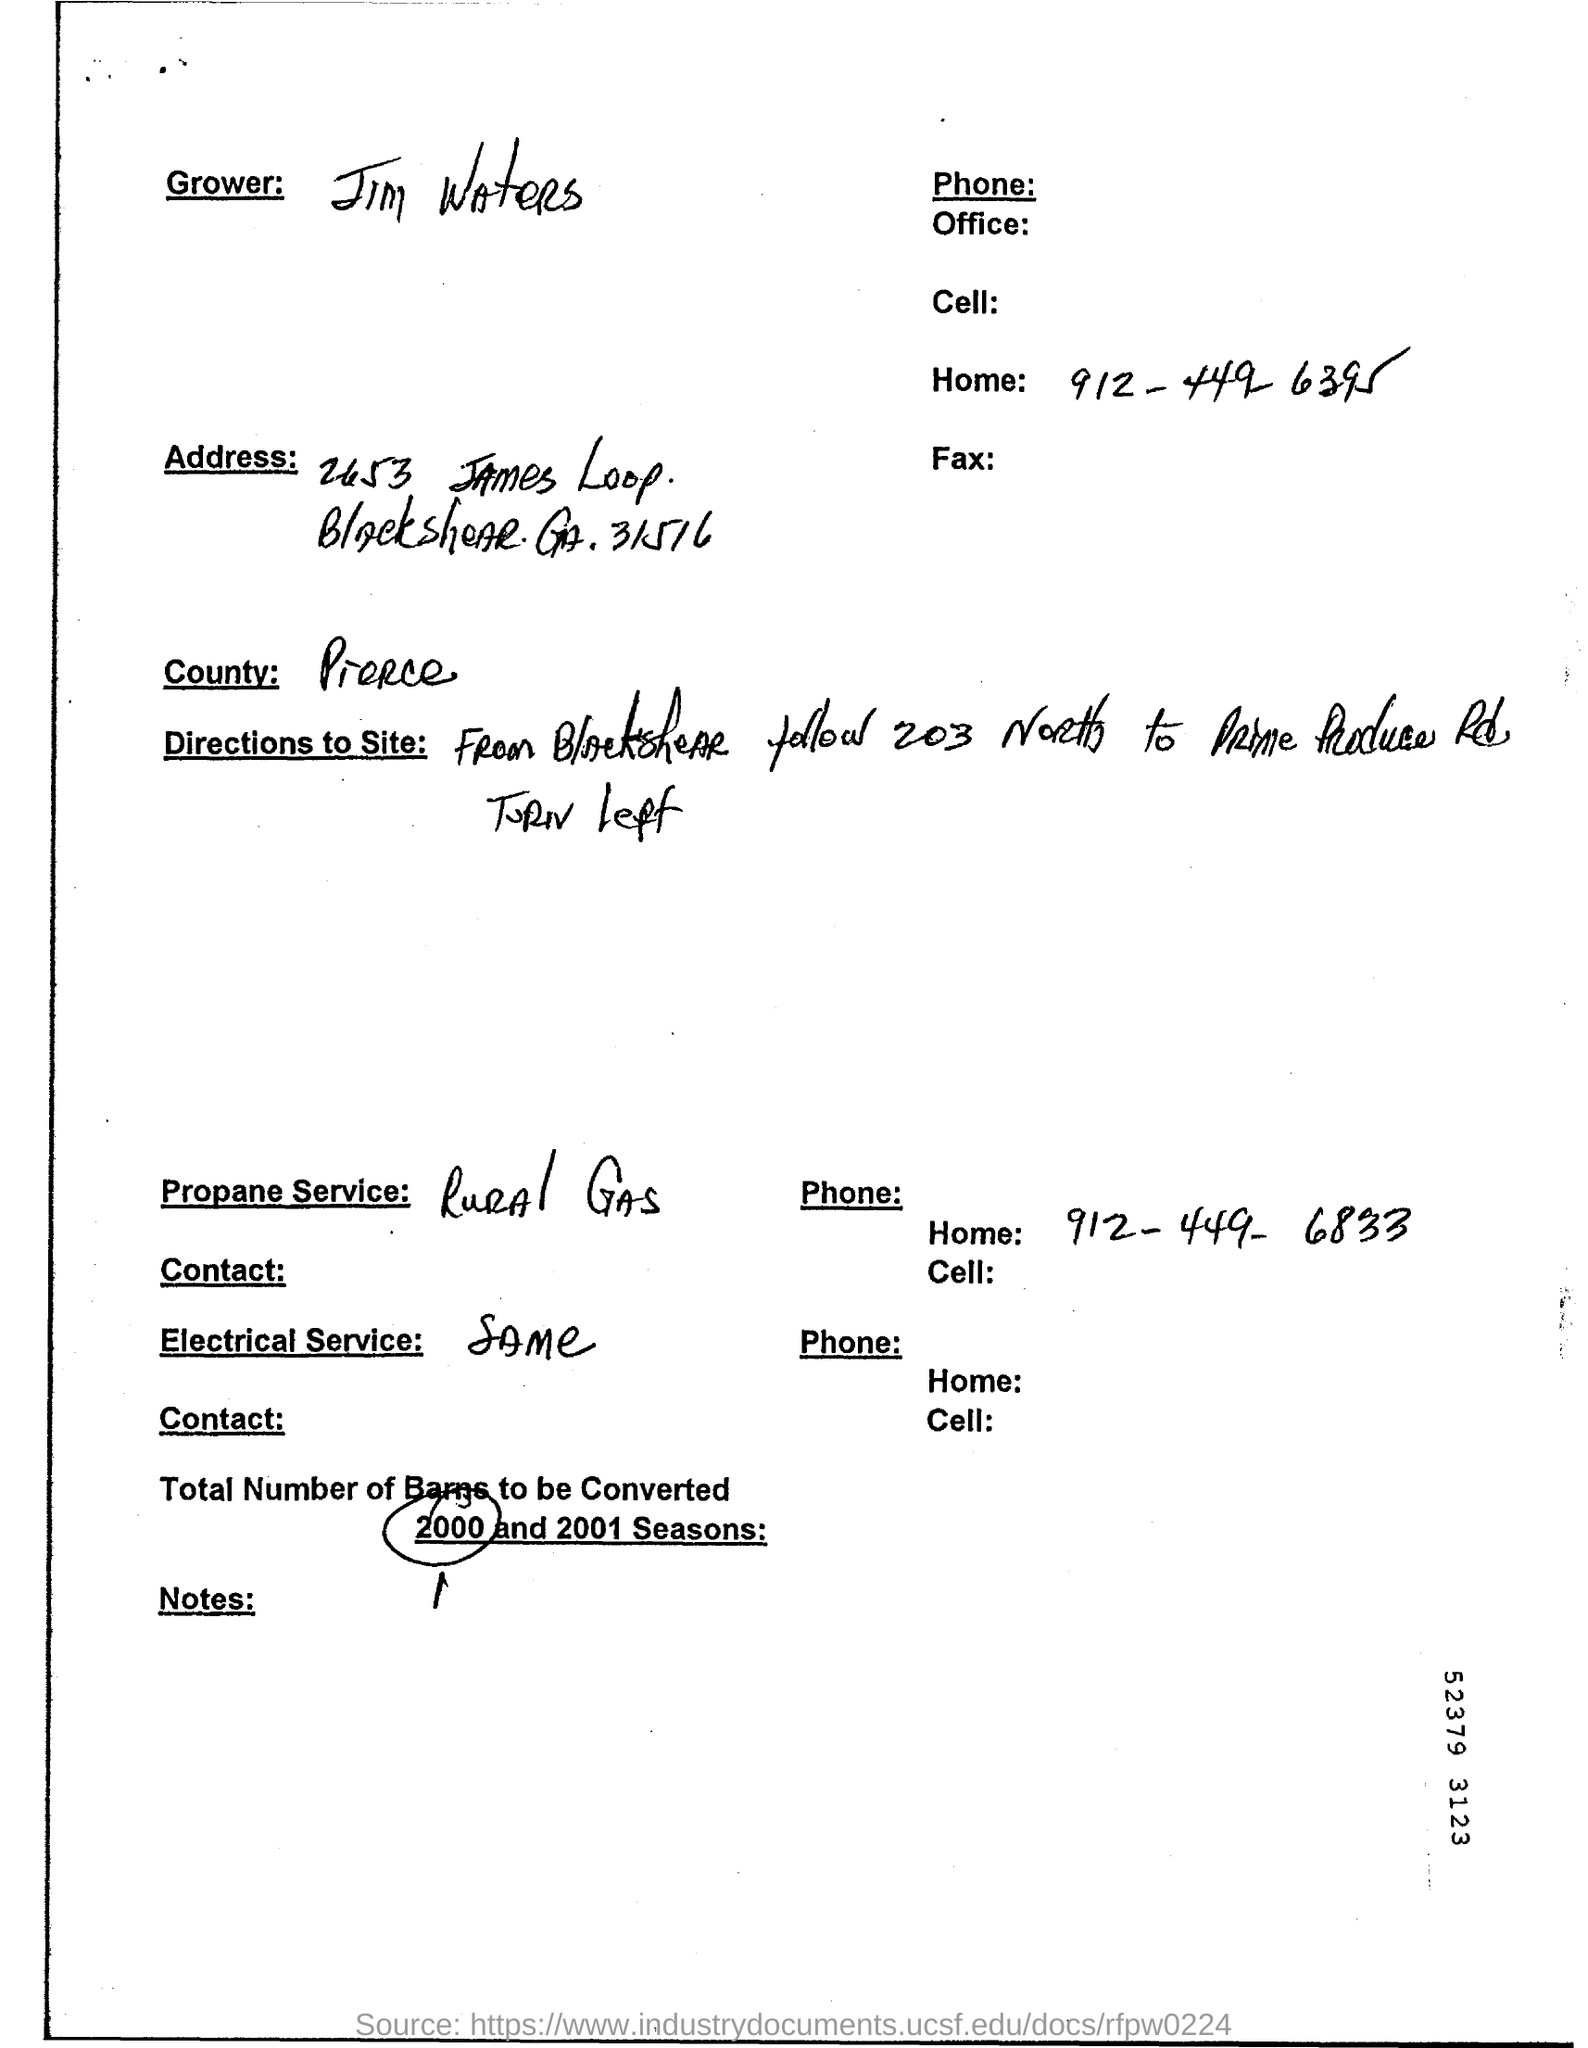Who is the Grower?
Your answer should be compact. Jim Waters. What is the Home phone number for Jim Waters?
Your answer should be compact. 912-449-6395. Which is the Propane Service?
Your answer should be very brief. Rural Gas. What is the Phone for Rural Gas?
Ensure brevity in your answer.  912-449-6833. 